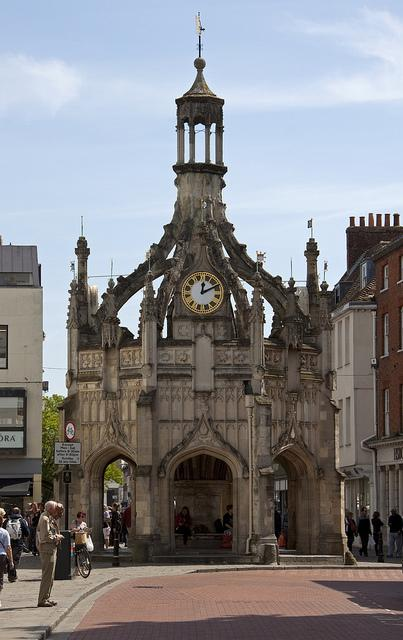Why would you look at this building? time 